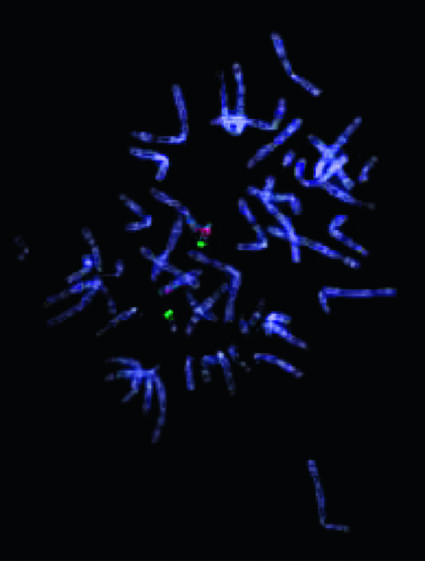re there two 22q13 signals?
Answer the question using a single word or phrase. Yes 